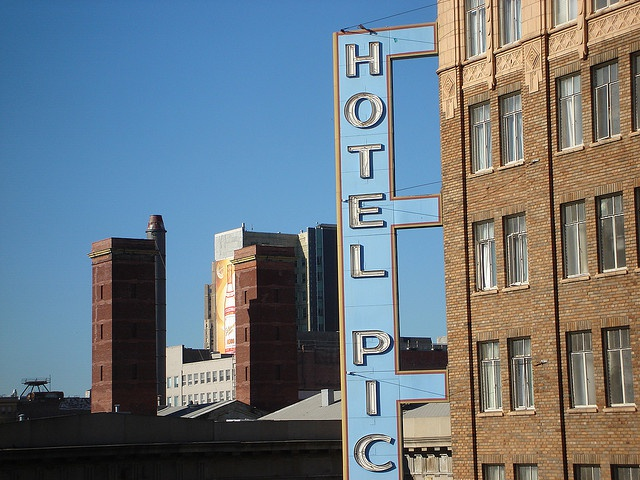Describe the objects in this image and their specific colors. I can see various objects in this image with different colors. 